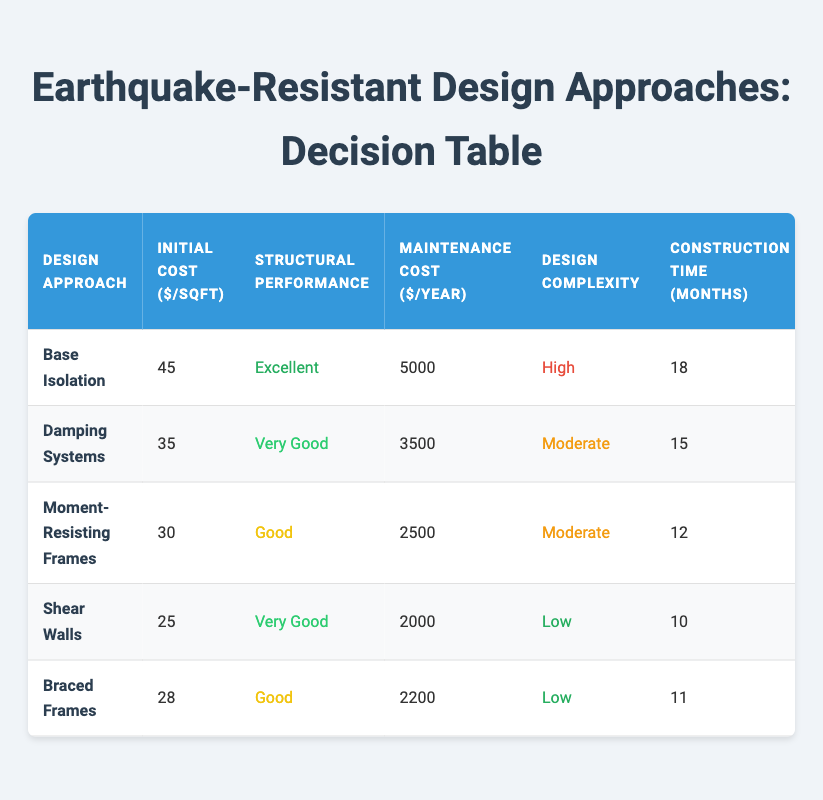What is the initial cost per square foot for Base Isolation? The initial cost for Base Isolation, as indicated in the table under the corresponding row, is $45 per square foot.
Answer: 45 Which design approach has the lowest maintenance cost per year? By looking at the maintenance cost column, Shear Walls have the lowest maintenance cost at $2000 per year.
Answer: Shear Walls Is the structural performance of Moment-Resisting Frames classified as 'Very Good'? The table shows that the structural performance of Moment-Resisting Frames is classified as 'Good', not 'Very Good'.
Answer: No Calculate the average initial cost of the design approaches listed. Adding the initial costs (45 + 35 + 30 + 25 + 28) gives a total of $163. Since there are 5 approaches, the average initial cost is 163/5 = 32.6.
Answer: 32.6 Which approach has a higher structural performance, Damping Systems or Braced Frames? The table indicates that Damping Systems have a structural performance classified as 'Very Good', while Braced Frames are classified as 'Good'. Since 'Very Good' ranks higher than 'Good', therefore, Damping Systems outperform Braced Frames.
Answer: Damping Systems Is the construction time for Shear Walls shorter than that for Base Isolation? The construction time for Shear Walls is 10 months, while for Base Isolation it is 18 months. Since 10 is less than 18, the construction time for Shear Walls is indeed shorter.
Answer: Yes Which design approaches are categorized as having 'Moderate' adaptability to different building types? Referring to the adaptability column, Base Isolation and Shear Walls are both listed as having 'Moderate' adaptability.
Answer: Base Isolation, Shear Walls What is the difference in initial cost between the most expensive and the least expensive design approaches? The most expensive design approach is Base Isolation at $45 per square foot and the least expensive is Shear Walls at $25 per square foot. The difference is 45 - 25 = 20.
Answer: 20 Which design approach has the best performance and evaluates the interplay of cost and adaptation? Base Isolation is noted for 'Excellent' structural performance, but it has a high initial cost and limited material availability, making it less adaptive. Moment-Resisting Frames show a balance with 'Good' performance, lower costs, and very high adaptability. Comparing these, Moment-Resisting Frames could be seen as the more balanced approach when considering cost and overall adaptability.
Answer: Moment-Resisting Frames 